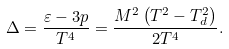Convert formula to latex. <formula><loc_0><loc_0><loc_500><loc_500>\Delta = \frac { \varepsilon - 3 p } { T ^ { 4 } } = \frac { M ^ { 2 } \left ( T ^ { 2 } - T _ { d } ^ { 2 } \right ) } { 2 T ^ { 4 } } .</formula> 